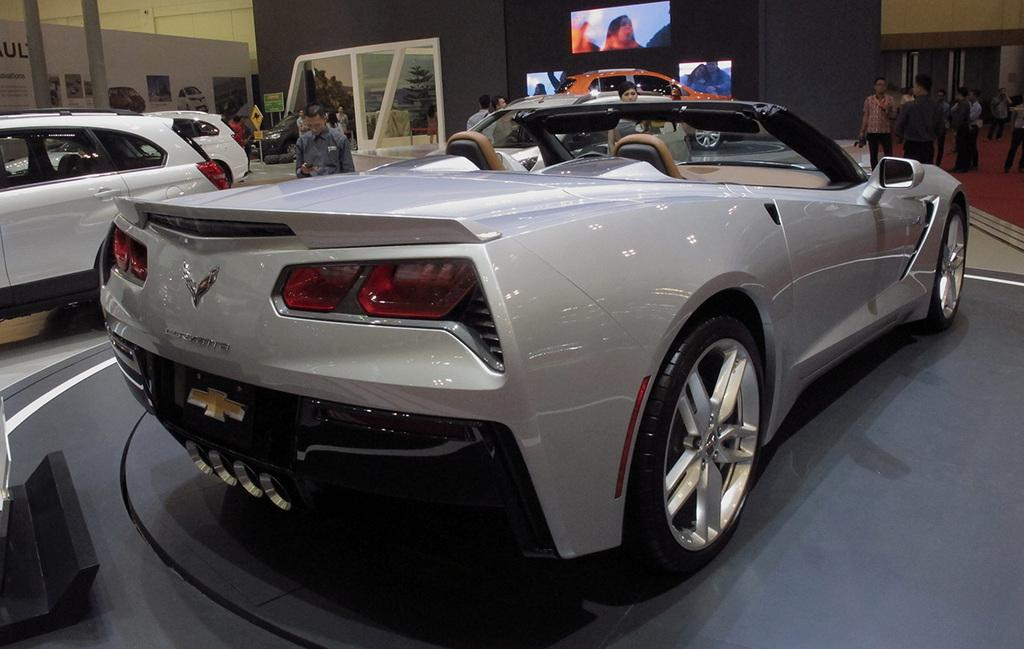What type of location is depicted in the image? The image shows an inside view of a car showroom. What can be seen in the foreground of the image? There is a silver car parked in the front. What is on the wall in the background of the image? There are television screens on a black wall in the background. Where is the apple placed in the image? There is no apple present in the image. Can you tell me how many cans are visible in the image? There are no cans visible in the image. 